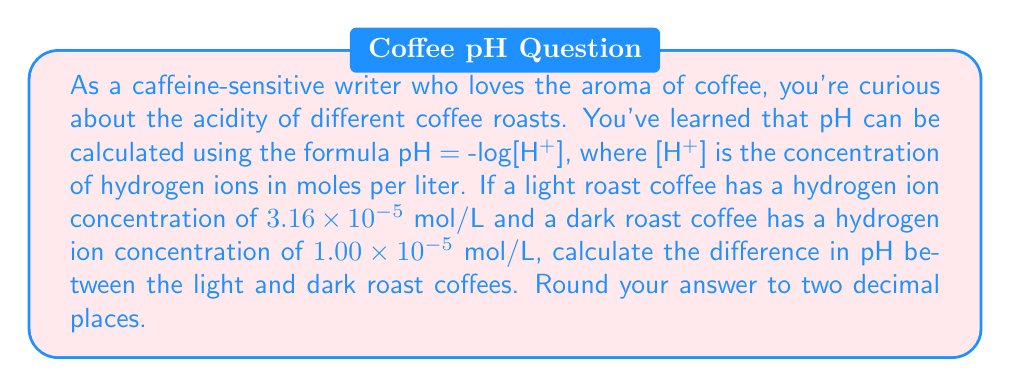Solve this math problem. Let's approach this problem step-by-step:

1) We'll use the formula pH = -log[H+] for both coffee roasts.

2) For the light roast coffee:
   [H+] = $3.16 \times 10^{-5}$ mol/L
   pH = -log($3.16 \times 10^{-5}$)
   $$\begin{align}
   \text{pH}_{\text{light}} &= -\log(3.16 \times 10^{-5}) \\
   &= -(\log(3.16) + \log(10^{-5})) \\
   &= -(0.4997 - 5) \\
   &= 4.5003
   \end{align}$$

3) For the dark roast coffee:
   [H+] = $1.00 \times 10^{-5}$ mol/L
   pH = -log($1.00 \times 10^{-5}$)
   $$\begin{align}
   \text{pH}_{\text{dark}} &= -\log(1.00 \times 10^{-5}) \\
   &= -(\log(1) + \log(10^{-5})) \\
   &= -(0 - 5) \\
   &= 5.0000
   \end{align}$$

4) To find the difference in pH:
   $$\begin{align}
   \text{pH difference} &= \text{pH}_{\text{dark}} - \text{pH}_{\text{light}} \\
   &= 5.0000 - 4.5003 \\
   &= 0.4997
   \end{align}$$

5) Rounding to two decimal places: 0.50
Answer: The difference in pH between the dark roast and light roast coffees is 0.50. 